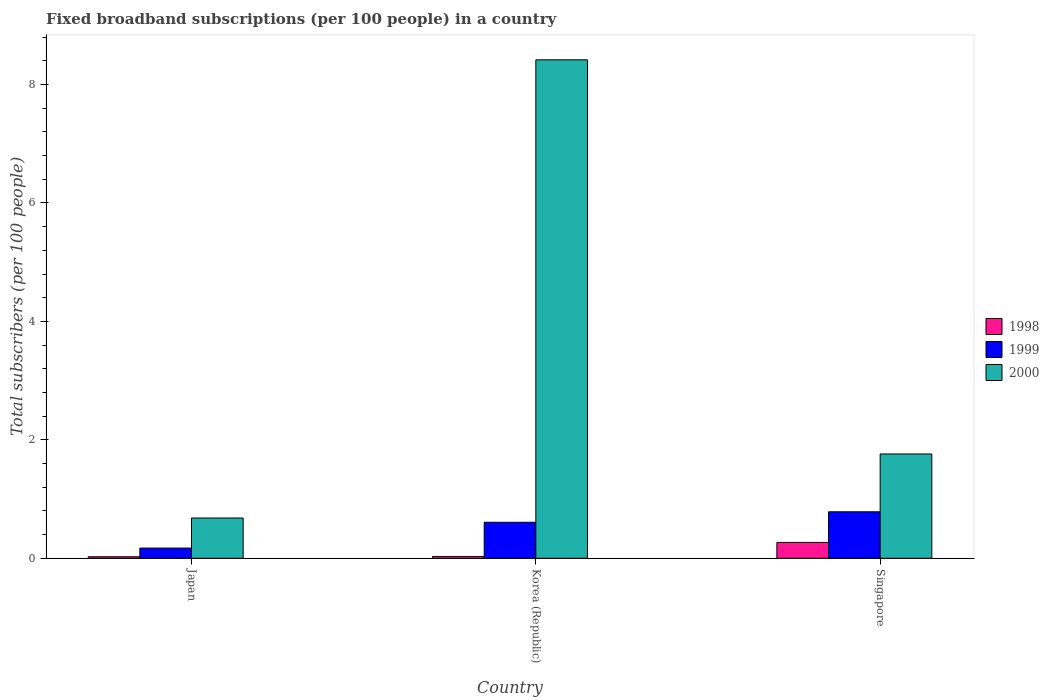How many different coloured bars are there?
Provide a short and direct response. 3. How many groups of bars are there?
Give a very brief answer. 3. What is the label of the 3rd group of bars from the left?
Your answer should be very brief. Singapore. In how many cases, is the number of bars for a given country not equal to the number of legend labels?
Give a very brief answer. 0. What is the number of broadband subscriptions in 1998 in Japan?
Your answer should be compact. 0.03. Across all countries, what is the maximum number of broadband subscriptions in 1999?
Provide a short and direct response. 0.78. Across all countries, what is the minimum number of broadband subscriptions in 1999?
Keep it short and to the point. 0.17. In which country was the number of broadband subscriptions in 1998 maximum?
Your answer should be compact. Singapore. What is the total number of broadband subscriptions in 2000 in the graph?
Provide a succinct answer. 10.86. What is the difference between the number of broadband subscriptions in 1999 in Korea (Republic) and that in Singapore?
Provide a short and direct response. -0.18. What is the difference between the number of broadband subscriptions in 1998 in Singapore and the number of broadband subscriptions in 1999 in Korea (Republic)?
Offer a terse response. -0.34. What is the average number of broadband subscriptions in 1999 per country?
Provide a succinct answer. 0.52. What is the difference between the number of broadband subscriptions of/in 2000 and number of broadband subscriptions of/in 1998 in Japan?
Ensure brevity in your answer.  0.65. In how many countries, is the number of broadband subscriptions in 2000 greater than 1.2000000000000002?
Provide a succinct answer. 2. What is the ratio of the number of broadband subscriptions in 1998 in Japan to that in Korea (Republic)?
Offer a very short reply. 0.83. What is the difference between the highest and the second highest number of broadband subscriptions in 1998?
Offer a terse response. 0.24. What is the difference between the highest and the lowest number of broadband subscriptions in 1998?
Provide a short and direct response. 0.24. What does the 2nd bar from the left in Korea (Republic) represents?
Provide a succinct answer. 1999. What does the 1st bar from the right in Japan represents?
Offer a very short reply. 2000. Are all the bars in the graph horizontal?
Offer a very short reply. No. What is the difference between two consecutive major ticks on the Y-axis?
Your answer should be very brief. 2. Are the values on the major ticks of Y-axis written in scientific E-notation?
Ensure brevity in your answer.  No. Does the graph contain grids?
Your response must be concise. No. Where does the legend appear in the graph?
Your answer should be very brief. Center right. How are the legend labels stacked?
Your answer should be compact. Vertical. What is the title of the graph?
Offer a very short reply. Fixed broadband subscriptions (per 100 people) in a country. What is the label or title of the Y-axis?
Provide a short and direct response. Total subscribers (per 100 people). What is the Total subscribers (per 100 people) in 1998 in Japan?
Make the answer very short. 0.03. What is the Total subscribers (per 100 people) in 1999 in Japan?
Make the answer very short. 0.17. What is the Total subscribers (per 100 people) of 2000 in Japan?
Keep it short and to the point. 0.68. What is the Total subscribers (per 100 people) in 1998 in Korea (Republic)?
Your answer should be very brief. 0.03. What is the Total subscribers (per 100 people) in 1999 in Korea (Republic)?
Give a very brief answer. 0.61. What is the Total subscribers (per 100 people) of 2000 in Korea (Republic)?
Your response must be concise. 8.42. What is the Total subscribers (per 100 people) of 1998 in Singapore?
Your answer should be very brief. 0.27. What is the Total subscribers (per 100 people) of 1999 in Singapore?
Provide a short and direct response. 0.78. What is the Total subscribers (per 100 people) of 2000 in Singapore?
Offer a terse response. 1.76. Across all countries, what is the maximum Total subscribers (per 100 people) in 1998?
Offer a terse response. 0.27. Across all countries, what is the maximum Total subscribers (per 100 people) of 1999?
Provide a short and direct response. 0.78. Across all countries, what is the maximum Total subscribers (per 100 people) in 2000?
Offer a terse response. 8.42. Across all countries, what is the minimum Total subscribers (per 100 people) of 1998?
Give a very brief answer. 0.03. Across all countries, what is the minimum Total subscribers (per 100 people) in 1999?
Provide a short and direct response. 0.17. Across all countries, what is the minimum Total subscribers (per 100 people) of 2000?
Give a very brief answer. 0.68. What is the total Total subscribers (per 100 people) of 1998 in the graph?
Provide a short and direct response. 0.32. What is the total Total subscribers (per 100 people) of 1999 in the graph?
Keep it short and to the point. 1.56. What is the total Total subscribers (per 100 people) in 2000 in the graph?
Ensure brevity in your answer.  10.86. What is the difference between the Total subscribers (per 100 people) in 1998 in Japan and that in Korea (Republic)?
Make the answer very short. -0.01. What is the difference between the Total subscribers (per 100 people) of 1999 in Japan and that in Korea (Republic)?
Provide a short and direct response. -0.44. What is the difference between the Total subscribers (per 100 people) of 2000 in Japan and that in Korea (Republic)?
Ensure brevity in your answer.  -7.74. What is the difference between the Total subscribers (per 100 people) in 1998 in Japan and that in Singapore?
Ensure brevity in your answer.  -0.24. What is the difference between the Total subscribers (per 100 people) in 1999 in Japan and that in Singapore?
Provide a succinct answer. -0.61. What is the difference between the Total subscribers (per 100 people) in 2000 in Japan and that in Singapore?
Provide a succinct answer. -1.08. What is the difference between the Total subscribers (per 100 people) of 1998 in Korea (Republic) and that in Singapore?
Offer a very short reply. -0.24. What is the difference between the Total subscribers (per 100 people) in 1999 in Korea (Republic) and that in Singapore?
Offer a very short reply. -0.18. What is the difference between the Total subscribers (per 100 people) of 2000 in Korea (Republic) and that in Singapore?
Ensure brevity in your answer.  6.66. What is the difference between the Total subscribers (per 100 people) in 1998 in Japan and the Total subscribers (per 100 people) in 1999 in Korea (Republic)?
Provide a short and direct response. -0.58. What is the difference between the Total subscribers (per 100 people) in 1998 in Japan and the Total subscribers (per 100 people) in 2000 in Korea (Republic)?
Make the answer very short. -8.39. What is the difference between the Total subscribers (per 100 people) in 1999 in Japan and the Total subscribers (per 100 people) in 2000 in Korea (Republic)?
Your answer should be very brief. -8.25. What is the difference between the Total subscribers (per 100 people) in 1998 in Japan and the Total subscribers (per 100 people) in 1999 in Singapore?
Make the answer very short. -0.76. What is the difference between the Total subscribers (per 100 people) in 1998 in Japan and the Total subscribers (per 100 people) in 2000 in Singapore?
Ensure brevity in your answer.  -1.74. What is the difference between the Total subscribers (per 100 people) in 1999 in Japan and the Total subscribers (per 100 people) in 2000 in Singapore?
Ensure brevity in your answer.  -1.59. What is the difference between the Total subscribers (per 100 people) in 1998 in Korea (Republic) and the Total subscribers (per 100 people) in 1999 in Singapore?
Give a very brief answer. -0.75. What is the difference between the Total subscribers (per 100 people) in 1998 in Korea (Republic) and the Total subscribers (per 100 people) in 2000 in Singapore?
Your answer should be very brief. -1.73. What is the difference between the Total subscribers (per 100 people) in 1999 in Korea (Republic) and the Total subscribers (per 100 people) in 2000 in Singapore?
Your answer should be compact. -1.15. What is the average Total subscribers (per 100 people) of 1998 per country?
Give a very brief answer. 0.11. What is the average Total subscribers (per 100 people) in 1999 per country?
Your answer should be compact. 0.52. What is the average Total subscribers (per 100 people) in 2000 per country?
Make the answer very short. 3.62. What is the difference between the Total subscribers (per 100 people) in 1998 and Total subscribers (per 100 people) in 1999 in Japan?
Provide a short and direct response. -0.15. What is the difference between the Total subscribers (per 100 people) in 1998 and Total subscribers (per 100 people) in 2000 in Japan?
Make the answer very short. -0.65. What is the difference between the Total subscribers (per 100 people) in 1999 and Total subscribers (per 100 people) in 2000 in Japan?
Offer a terse response. -0.51. What is the difference between the Total subscribers (per 100 people) of 1998 and Total subscribers (per 100 people) of 1999 in Korea (Republic)?
Provide a short and direct response. -0.58. What is the difference between the Total subscribers (per 100 people) in 1998 and Total subscribers (per 100 people) in 2000 in Korea (Republic)?
Give a very brief answer. -8.39. What is the difference between the Total subscribers (per 100 people) in 1999 and Total subscribers (per 100 people) in 2000 in Korea (Republic)?
Ensure brevity in your answer.  -7.81. What is the difference between the Total subscribers (per 100 people) of 1998 and Total subscribers (per 100 people) of 1999 in Singapore?
Offer a very short reply. -0.52. What is the difference between the Total subscribers (per 100 people) of 1998 and Total subscribers (per 100 people) of 2000 in Singapore?
Provide a succinct answer. -1.49. What is the difference between the Total subscribers (per 100 people) of 1999 and Total subscribers (per 100 people) of 2000 in Singapore?
Provide a short and direct response. -0.98. What is the ratio of the Total subscribers (per 100 people) of 1998 in Japan to that in Korea (Republic)?
Offer a terse response. 0.83. What is the ratio of the Total subscribers (per 100 people) of 1999 in Japan to that in Korea (Republic)?
Your response must be concise. 0.28. What is the ratio of the Total subscribers (per 100 people) in 2000 in Japan to that in Korea (Republic)?
Your response must be concise. 0.08. What is the ratio of the Total subscribers (per 100 people) in 1998 in Japan to that in Singapore?
Make the answer very short. 0.1. What is the ratio of the Total subscribers (per 100 people) in 1999 in Japan to that in Singapore?
Make the answer very short. 0.22. What is the ratio of the Total subscribers (per 100 people) in 2000 in Japan to that in Singapore?
Offer a very short reply. 0.39. What is the ratio of the Total subscribers (per 100 people) of 1998 in Korea (Republic) to that in Singapore?
Provide a short and direct response. 0.12. What is the ratio of the Total subscribers (per 100 people) in 1999 in Korea (Republic) to that in Singapore?
Give a very brief answer. 0.77. What is the ratio of the Total subscribers (per 100 people) of 2000 in Korea (Republic) to that in Singapore?
Your answer should be compact. 4.78. What is the difference between the highest and the second highest Total subscribers (per 100 people) in 1998?
Keep it short and to the point. 0.24. What is the difference between the highest and the second highest Total subscribers (per 100 people) of 1999?
Ensure brevity in your answer.  0.18. What is the difference between the highest and the second highest Total subscribers (per 100 people) of 2000?
Provide a succinct answer. 6.66. What is the difference between the highest and the lowest Total subscribers (per 100 people) in 1998?
Keep it short and to the point. 0.24. What is the difference between the highest and the lowest Total subscribers (per 100 people) in 1999?
Your answer should be compact. 0.61. What is the difference between the highest and the lowest Total subscribers (per 100 people) of 2000?
Ensure brevity in your answer.  7.74. 